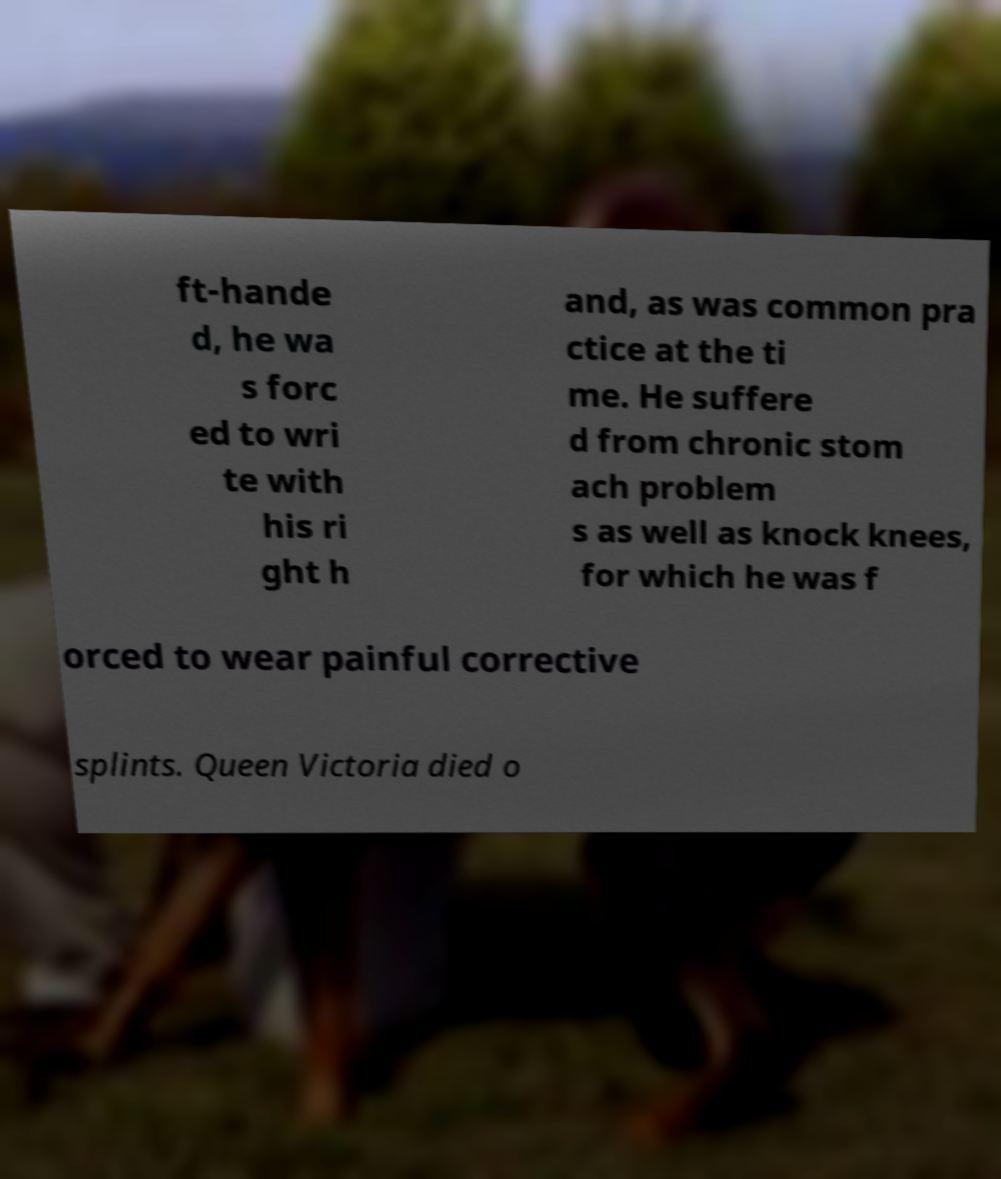Could you extract and type out the text from this image? ft-hande d, he wa s forc ed to wri te with his ri ght h and, as was common pra ctice at the ti me. He suffere d from chronic stom ach problem s as well as knock knees, for which he was f orced to wear painful corrective splints. Queen Victoria died o 